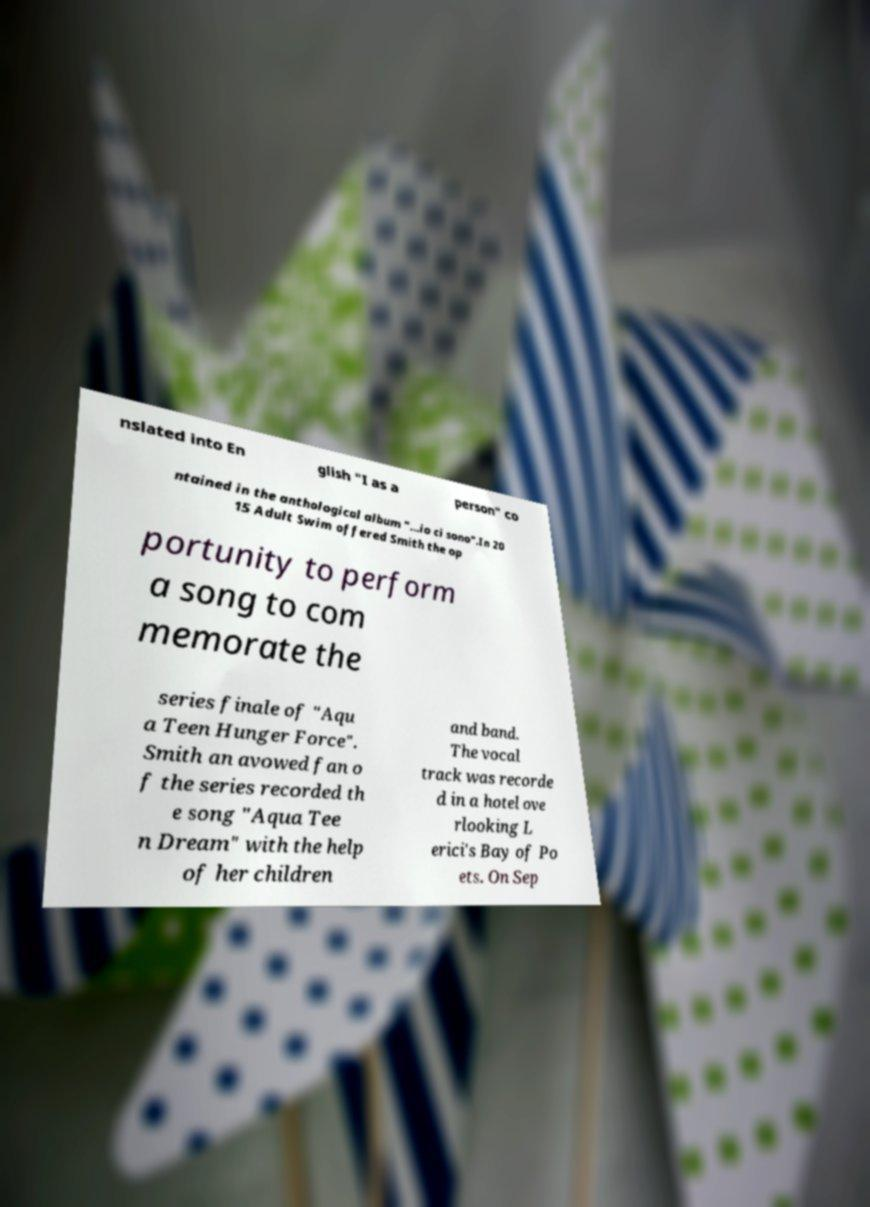Please identify and transcribe the text found in this image. nslated into En glish "I as a person" co ntained in the anthological album "...io ci sono".In 20 15 Adult Swim offered Smith the op portunity to perform a song to com memorate the series finale of "Aqu a Teen Hunger Force". Smith an avowed fan o f the series recorded th e song "Aqua Tee n Dream" with the help of her children and band. The vocal track was recorde d in a hotel ove rlooking L erici's Bay of Po ets. On Sep 